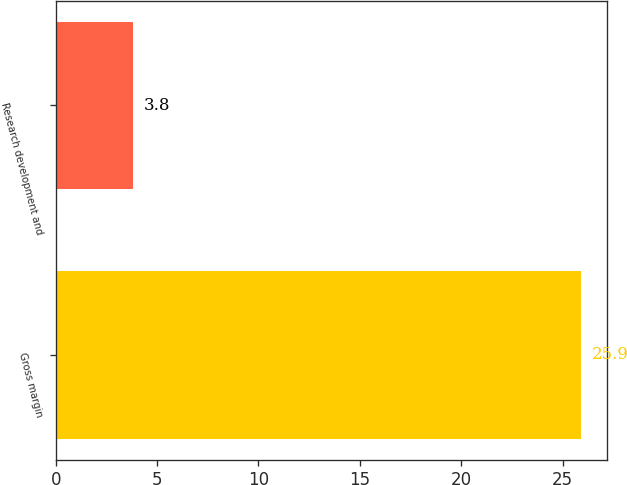Convert chart. <chart><loc_0><loc_0><loc_500><loc_500><bar_chart><fcel>Gross margin<fcel>Research development and<nl><fcel>25.9<fcel>3.8<nl></chart> 